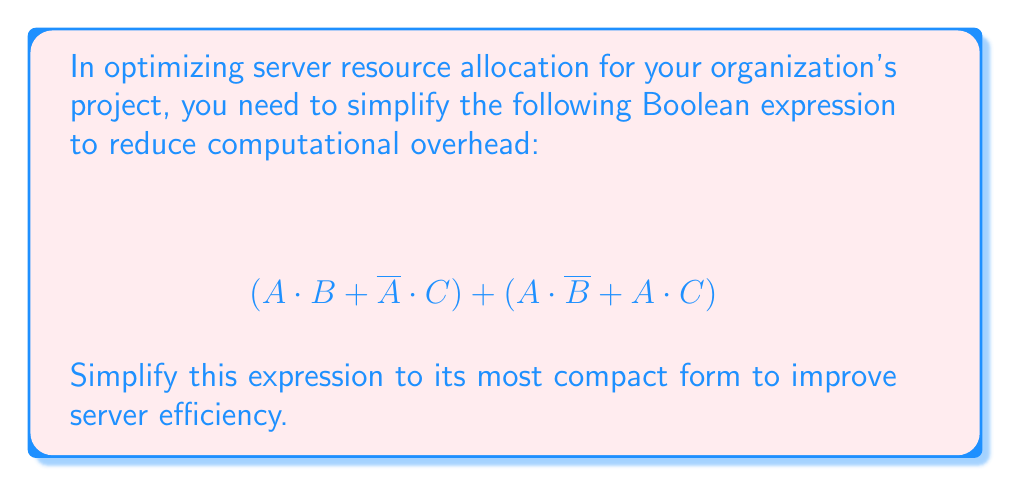Could you help me with this problem? Let's simplify the expression step by step:

1) First, let's distribute A in the second part of the expression:
   $$(A \cdot B + \overline{A} \cdot C) + (A \cdot \overline{B} + A \cdot C)$$
   $$= (A \cdot B + \overline{A} \cdot C) + A \cdot (\overline{B} + C)$$

2) Now, we can apply the distributive law to the entire expression:
   $$= A \cdot B + \overline{A} \cdot C + A \cdot \overline{B} + A \cdot C$$

3) We can rearrange the terms:
   $$= A \cdot B + A \cdot \overline{B} + A \cdot C + \overline{A} \cdot C$$

4) The first two terms $(A \cdot B + A \cdot \overline{B})$ can be simplified using the law of excluded middle: $X + \overline{X} = 1$
   $$= A + A \cdot C + \overline{A} \cdot C$$

5) Now, we can factor out C from the last two terms:
   $$= A + C \cdot (A + \overline{A})$$

6) Again, $(A + \overline{A}) = 1$, so:
   $$= A + C$$

This is the most simplified form of the expression.
Answer: $A + C$ 